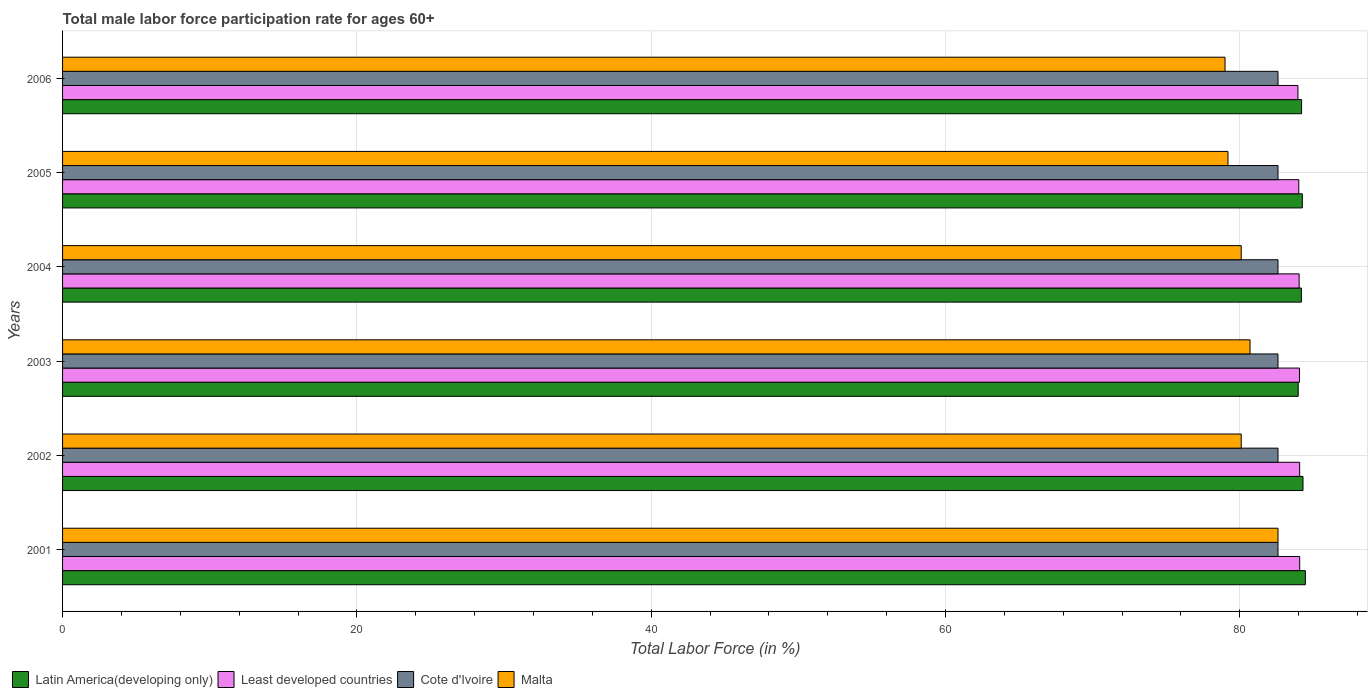How many different coloured bars are there?
Provide a succinct answer. 4. How many groups of bars are there?
Your answer should be compact. 6. How many bars are there on the 6th tick from the bottom?
Provide a short and direct response. 4. What is the label of the 4th group of bars from the top?
Provide a short and direct response. 2003. In how many cases, is the number of bars for a given year not equal to the number of legend labels?
Give a very brief answer. 0. What is the male labor force participation rate in Least developed countries in 2001?
Make the answer very short. 84.07. Across all years, what is the maximum male labor force participation rate in Cote d'Ivoire?
Your answer should be very brief. 82.6. Across all years, what is the minimum male labor force participation rate in Malta?
Provide a short and direct response. 79. In which year was the male labor force participation rate in Cote d'Ivoire minimum?
Your answer should be compact. 2001. What is the total male labor force participation rate in Malta in the graph?
Ensure brevity in your answer.  481.7. What is the difference between the male labor force participation rate in Cote d'Ivoire in 2001 and that in 2002?
Your answer should be compact. 0. What is the difference between the male labor force participation rate in Latin America(developing only) in 2003 and the male labor force participation rate in Least developed countries in 2002?
Make the answer very short. -0.1. What is the average male labor force participation rate in Least developed countries per year?
Provide a short and direct response. 84.04. In the year 2001, what is the difference between the male labor force participation rate in Least developed countries and male labor force participation rate in Latin America(developing only)?
Provide a short and direct response. -0.38. In how many years, is the male labor force participation rate in Latin America(developing only) greater than 24 %?
Your answer should be compact. 6. What is the ratio of the male labor force participation rate in Cote d'Ivoire in 2001 to that in 2003?
Your answer should be very brief. 1. Is the male labor force participation rate in Cote d'Ivoire in 2002 less than that in 2005?
Give a very brief answer. No. What is the difference between the highest and the second highest male labor force participation rate in Least developed countries?
Provide a succinct answer. 0. What is the difference between the highest and the lowest male labor force participation rate in Latin America(developing only)?
Give a very brief answer. 0.49. In how many years, is the male labor force participation rate in Cote d'Ivoire greater than the average male labor force participation rate in Cote d'Ivoire taken over all years?
Your answer should be very brief. 0. What does the 4th bar from the top in 2004 represents?
Keep it short and to the point. Latin America(developing only). What does the 3rd bar from the bottom in 2006 represents?
Keep it short and to the point. Cote d'Ivoire. Is it the case that in every year, the sum of the male labor force participation rate in Least developed countries and male labor force participation rate in Cote d'Ivoire is greater than the male labor force participation rate in Malta?
Keep it short and to the point. Yes. Are all the bars in the graph horizontal?
Your answer should be very brief. Yes. Are the values on the major ticks of X-axis written in scientific E-notation?
Keep it short and to the point. No. Does the graph contain grids?
Give a very brief answer. Yes. How many legend labels are there?
Offer a very short reply. 4. What is the title of the graph?
Your answer should be compact. Total male labor force participation rate for ages 60+. Does "Trinidad and Tobago" appear as one of the legend labels in the graph?
Your answer should be compact. No. What is the label or title of the X-axis?
Provide a short and direct response. Total Labor Force (in %). What is the label or title of the Y-axis?
Provide a short and direct response. Years. What is the Total Labor Force (in %) in Latin America(developing only) in 2001?
Provide a short and direct response. 84.46. What is the Total Labor Force (in %) in Least developed countries in 2001?
Ensure brevity in your answer.  84.07. What is the Total Labor Force (in %) of Cote d'Ivoire in 2001?
Offer a terse response. 82.6. What is the Total Labor Force (in %) of Malta in 2001?
Offer a terse response. 82.6. What is the Total Labor Force (in %) in Latin America(developing only) in 2002?
Provide a succinct answer. 84.3. What is the Total Labor Force (in %) of Least developed countries in 2002?
Your answer should be very brief. 84.07. What is the Total Labor Force (in %) of Cote d'Ivoire in 2002?
Your answer should be very brief. 82.6. What is the Total Labor Force (in %) of Malta in 2002?
Your response must be concise. 80.1. What is the Total Labor Force (in %) of Latin America(developing only) in 2003?
Ensure brevity in your answer.  83.97. What is the Total Labor Force (in %) in Least developed countries in 2003?
Offer a very short reply. 84.06. What is the Total Labor Force (in %) of Cote d'Ivoire in 2003?
Ensure brevity in your answer.  82.6. What is the Total Labor Force (in %) in Malta in 2003?
Keep it short and to the point. 80.7. What is the Total Labor Force (in %) of Latin America(developing only) in 2004?
Provide a short and direct response. 84.19. What is the Total Labor Force (in %) of Least developed countries in 2004?
Your answer should be compact. 84.04. What is the Total Labor Force (in %) in Cote d'Ivoire in 2004?
Your answer should be compact. 82.6. What is the Total Labor Force (in %) in Malta in 2004?
Provide a short and direct response. 80.1. What is the Total Labor Force (in %) in Latin America(developing only) in 2005?
Your response must be concise. 84.25. What is the Total Labor Force (in %) in Least developed countries in 2005?
Give a very brief answer. 84.01. What is the Total Labor Force (in %) of Cote d'Ivoire in 2005?
Make the answer very short. 82.6. What is the Total Labor Force (in %) of Malta in 2005?
Keep it short and to the point. 79.2. What is the Total Labor Force (in %) of Latin America(developing only) in 2006?
Ensure brevity in your answer.  84.2. What is the Total Labor Force (in %) in Least developed countries in 2006?
Give a very brief answer. 83.96. What is the Total Labor Force (in %) of Cote d'Ivoire in 2006?
Ensure brevity in your answer.  82.6. What is the Total Labor Force (in %) of Malta in 2006?
Offer a very short reply. 79. Across all years, what is the maximum Total Labor Force (in %) of Latin America(developing only)?
Provide a short and direct response. 84.46. Across all years, what is the maximum Total Labor Force (in %) in Least developed countries?
Offer a very short reply. 84.07. Across all years, what is the maximum Total Labor Force (in %) of Cote d'Ivoire?
Give a very brief answer. 82.6. Across all years, what is the maximum Total Labor Force (in %) in Malta?
Offer a terse response. 82.6. Across all years, what is the minimum Total Labor Force (in %) of Latin America(developing only)?
Offer a terse response. 83.97. Across all years, what is the minimum Total Labor Force (in %) of Least developed countries?
Keep it short and to the point. 83.96. Across all years, what is the minimum Total Labor Force (in %) of Cote d'Ivoire?
Offer a very short reply. 82.6. Across all years, what is the minimum Total Labor Force (in %) in Malta?
Your response must be concise. 79. What is the total Total Labor Force (in %) of Latin America(developing only) in the graph?
Make the answer very short. 505.38. What is the total Total Labor Force (in %) of Least developed countries in the graph?
Give a very brief answer. 504.22. What is the total Total Labor Force (in %) of Cote d'Ivoire in the graph?
Keep it short and to the point. 495.6. What is the total Total Labor Force (in %) in Malta in the graph?
Your answer should be very brief. 481.7. What is the difference between the Total Labor Force (in %) of Latin America(developing only) in 2001 and that in 2002?
Your response must be concise. 0.16. What is the difference between the Total Labor Force (in %) of Least developed countries in 2001 and that in 2002?
Provide a short and direct response. 0. What is the difference between the Total Labor Force (in %) of Cote d'Ivoire in 2001 and that in 2002?
Provide a short and direct response. 0. What is the difference between the Total Labor Force (in %) of Malta in 2001 and that in 2002?
Provide a succinct answer. 2.5. What is the difference between the Total Labor Force (in %) of Latin America(developing only) in 2001 and that in 2003?
Your response must be concise. 0.49. What is the difference between the Total Labor Force (in %) of Least developed countries in 2001 and that in 2003?
Provide a succinct answer. 0.01. What is the difference between the Total Labor Force (in %) in Latin America(developing only) in 2001 and that in 2004?
Offer a terse response. 0.27. What is the difference between the Total Labor Force (in %) in Least developed countries in 2001 and that in 2004?
Keep it short and to the point. 0.04. What is the difference between the Total Labor Force (in %) of Cote d'Ivoire in 2001 and that in 2004?
Provide a succinct answer. 0. What is the difference between the Total Labor Force (in %) of Latin America(developing only) in 2001 and that in 2005?
Your answer should be very brief. 0.21. What is the difference between the Total Labor Force (in %) of Least developed countries in 2001 and that in 2005?
Offer a terse response. 0.06. What is the difference between the Total Labor Force (in %) of Malta in 2001 and that in 2005?
Your answer should be very brief. 3.4. What is the difference between the Total Labor Force (in %) of Latin America(developing only) in 2001 and that in 2006?
Your answer should be very brief. 0.26. What is the difference between the Total Labor Force (in %) of Least developed countries in 2001 and that in 2006?
Keep it short and to the point. 0.12. What is the difference between the Total Labor Force (in %) in Latin America(developing only) in 2002 and that in 2003?
Offer a terse response. 0.33. What is the difference between the Total Labor Force (in %) in Latin America(developing only) in 2002 and that in 2004?
Give a very brief answer. 0.11. What is the difference between the Total Labor Force (in %) of Least developed countries in 2002 and that in 2004?
Your answer should be very brief. 0.04. What is the difference between the Total Labor Force (in %) in Latin America(developing only) in 2002 and that in 2005?
Ensure brevity in your answer.  0.05. What is the difference between the Total Labor Force (in %) in Least developed countries in 2002 and that in 2005?
Ensure brevity in your answer.  0.06. What is the difference between the Total Labor Force (in %) in Latin America(developing only) in 2002 and that in 2006?
Your answer should be compact. 0.1. What is the difference between the Total Labor Force (in %) of Least developed countries in 2002 and that in 2006?
Your response must be concise. 0.12. What is the difference between the Total Labor Force (in %) in Latin America(developing only) in 2003 and that in 2004?
Offer a terse response. -0.22. What is the difference between the Total Labor Force (in %) in Least developed countries in 2003 and that in 2004?
Give a very brief answer. 0.03. What is the difference between the Total Labor Force (in %) of Latin America(developing only) in 2003 and that in 2005?
Keep it short and to the point. -0.28. What is the difference between the Total Labor Force (in %) in Least developed countries in 2003 and that in 2005?
Ensure brevity in your answer.  0.05. What is the difference between the Total Labor Force (in %) of Cote d'Ivoire in 2003 and that in 2005?
Your answer should be very brief. 0. What is the difference between the Total Labor Force (in %) of Malta in 2003 and that in 2005?
Your answer should be compact. 1.5. What is the difference between the Total Labor Force (in %) of Latin America(developing only) in 2003 and that in 2006?
Keep it short and to the point. -0.23. What is the difference between the Total Labor Force (in %) of Least developed countries in 2003 and that in 2006?
Keep it short and to the point. 0.11. What is the difference between the Total Labor Force (in %) of Latin America(developing only) in 2004 and that in 2005?
Keep it short and to the point. -0.06. What is the difference between the Total Labor Force (in %) in Least developed countries in 2004 and that in 2005?
Offer a very short reply. 0.02. What is the difference between the Total Labor Force (in %) of Cote d'Ivoire in 2004 and that in 2005?
Ensure brevity in your answer.  0. What is the difference between the Total Labor Force (in %) in Latin America(developing only) in 2004 and that in 2006?
Your answer should be very brief. -0.01. What is the difference between the Total Labor Force (in %) in Latin America(developing only) in 2005 and that in 2006?
Your response must be concise. 0.05. What is the difference between the Total Labor Force (in %) of Least developed countries in 2005 and that in 2006?
Offer a very short reply. 0.06. What is the difference between the Total Labor Force (in %) in Cote d'Ivoire in 2005 and that in 2006?
Make the answer very short. 0. What is the difference between the Total Labor Force (in %) in Latin America(developing only) in 2001 and the Total Labor Force (in %) in Least developed countries in 2002?
Your answer should be very brief. 0.39. What is the difference between the Total Labor Force (in %) of Latin America(developing only) in 2001 and the Total Labor Force (in %) of Cote d'Ivoire in 2002?
Offer a very short reply. 1.86. What is the difference between the Total Labor Force (in %) in Latin America(developing only) in 2001 and the Total Labor Force (in %) in Malta in 2002?
Your response must be concise. 4.36. What is the difference between the Total Labor Force (in %) in Least developed countries in 2001 and the Total Labor Force (in %) in Cote d'Ivoire in 2002?
Make the answer very short. 1.47. What is the difference between the Total Labor Force (in %) in Least developed countries in 2001 and the Total Labor Force (in %) in Malta in 2002?
Your answer should be compact. 3.97. What is the difference between the Total Labor Force (in %) of Cote d'Ivoire in 2001 and the Total Labor Force (in %) of Malta in 2002?
Keep it short and to the point. 2.5. What is the difference between the Total Labor Force (in %) of Latin America(developing only) in 2001 and the Total Labor Force (in %) of Least developed countries in 2003?
Keep it short and to the point. 0.4. What is the difference between the Total Labor Force (in %) in Latin America(developing only) in 2001 and the Total Labor Force (in %) in Cote d'Ivoire in 2003?
Ensure brevity in your answer.  1.86. What is the difference between the Total Labor Force (in %) in Latin America(developing only) in 2001 and the Total Labor Force (in %) in Malta in 2003?
Your response must be concise. 3.76. What is the difference between the Total Labor Force (in %) in Least developed countries in 2001 and the Total Labor Force (in %) in Cote d'Ivoire in 2003?
Your answer should be very brief. 1.47. What is the difference between the Total Labor Force (in %) in Least developed countries in 2001 and the Total Labor Force (in %) in Malta in 2003?
Give a very brief answer. 3.37. What is the difference between the Total Labor Force (in %) of Cote d'Ivoire in 2001 and the Total Labor Force (in %) of Malta in 2003?
Give a very brief answer. 1.9. What is the difference between the Total Labor Force (in %) in Latin America(developing only) in 2001 and the Total Labor Force (in %) in Least developed countries in 2004?
Keep it short and to the point. 0.42. What is the difference between the Total Labor Force (in %) of Latin America(developing only) in 2001 and the Total Labor Force (in %) of Cote d'Ivoire in 2004?
Your answer should be compact. 1.86. What is the difference between the Total Labor Force (in %) in Latin America(developing only) in 2001 and the Total Labor Force (in %) in Malta in 2004?
Your response must be concise. 4.36. What is the difference between the Total Labor Force (in %) of Least developed countries in 2001 and the Total Labor Force (in %) of Cote d'Ivoire in 2004?
Your answer should be compact. 1.47. What is the difference between the Total Labor Force (in %) of Least developed countries in 2001 and the Total Labor Force (in %) of Malta in 2004?
Offer a very short reply. 3.97. What is the difference between the Total Labor Force (in %) in Latin America(developing only) in 2001 and the Total Labor Force (in %) in Least developed countries in 2005?
Ensure brevity in your answer.  0.45. What is the difference between the Total Labor Force (in %) in Latin America(developing only) in 2001 and the Total Labor Force (in %) in Cote d'Ivoire in 2005?
Offer a terse response. 1.86. What is the difference between the Total Labor Force (in %) in Latin America(developing only) in 2001 and the Total Labor Force (in %) in Malta in 2005?
Provide a short and direct response. 5.26. What is the difference between the Total Labor Force (in %) of Least developed countries in 2001 and the Total Labor Force (in %) of Cote d'Ivoire in 2005?
Give a very brief answer. 1.47. What is the difference between the Total Labor Force (in %) in Least developed countries in 2001 and the Total Labor Force (in %) in Malta in 2005?
Keep it short and to the point. 4.87. What is the difference between the Total Labor Force (in %) of Cote d'Ivoire in 2001 and the Total Labor Force (in %) of Malta in 2005?
Provide a short and direct response. 3.4. What is the difference between the Total Labor Force (in %) in Latin America(developing only) in 2001 and the Total Labor Force (in %) in Least developed countries in 2006?
Provide a succinct answer. 0.5. What is the difference between the Total Labor Force (in %) of Latin America(developing only) in 2001 and the Total Labor Force (in %) of Cote d'Ivoire in 2006?
Your answer should be very brief. 1.86. What is the difference between the Total Labor Force (in %) in Latin America(developing only) in 2001 and the Total Labor Force (in %) in Malta in 2006?
Offer a terse response. 5.46. What is the difference between the Total Labor Force (in %) in Least developed countries in 2001 and the Total Labor Force (in %) in Cote d'Ivoire in 2006?
Offer a terse response. 1.47. What is the difference between the Total Labor Force (in %) in Least developed countries in 2001 and the Total Labor Force (in %) in Malta in 2006?
Offer a terse response. 5.07. What is the difference between the Total Labor Force (in %) in Latin America(developing only) in 2002 and the Total Labor Force (in %) in Least developed countries in 2003?
Give a very brief answer. 0.24. What is the difference between the Total Labor Force (in %) of Latin America(developing only) in 2002 and the Total Labor Force (in %) of Cote d'Ivoire in 2003?
Provide a short and direct response. 1.7. What is the difference between the Total Labor Force (in %) of Latin America(developing only) in 2002 and the Total Labor Force (in %) of Malta in 2003?
Your answer should be compact. 3.6. What is the difference between the Total Labor Force (in %) of Least developed countries in 2002 and the Total Labor Force (in %) of Cote d'Ivoire in 2003?
Make the answer very short. 1.47. What is the difference between the Total Labor Force (in %) of Least developed countries in 2002 and the Total Labor Force (in %) of Malta in 2003?
Provide a short and direct response. 3.37. What is the difference between the Total Labor Force (in %) in Latin America(developing only) in 2002 and the Total Labor Force (in %) in Least developed countries in 2004?
Offer a terse response. 0.26. What is the difference between the Total Labor Force (in %) of Latin America(developing only) in 2002 and the Total Labor Force (in %) of Cote d'Ivoire in 2004?
Your answer should be very brief. 1.7. What is the difference between the Total Labor Force (in %) in Latin America(developing only) in 2002 and the Total Labor Force (in %) in Malta in 2004?
Ensure brevity in your answer.  4.2. What is the difference between the Total Labor Force (in %) of Least developed countries in 2002 and the Total Labor Force (in %) of Cote d'Ivoire in 2004?
Your response must be concise. 1.47. What is the difference between the Total Labor Force (in %) in Least developed countries in 2002 and the Total Labor Force (in %) in Malta in 2004?
Give a very brief answer. 3.97. What is the difference between the Total Labor Force (in %) of Cote d'Ivoire in 2002 and the Total Labor Force (in %) of Malta in 2004?
Your answer should be compact. 2.5. What is the difference between the Total Labor Force (in %) in Latin America(developing only) in 2002 and the Total Labor Force (in %) in Least developed countries in 2005?
Provide a succinct answer. 0.29. What is the difference between the Total Labor Force (in %) of Latin America(developing only) in 2002 and the Total Labor Force (in %) of Cote d'Ivoire in 2005?
Keep it short and to the point. 1.7. What is the difference between the Total Labor Force (in %) of Latin America(developing only) in 2002 and the Total Labor Force (in %) of Malta in 2005?
Your response must be concise. 5.1. What is the difference between the Total Labor Force (in %) of Least developed countries in 2002 and the Total Labor Force (in %) of Cote d'Ivoire in 2005?
Offer a very short reply. 1.47. What is the difference between the Total Labor Force (in %) of Least developed countries in 2002 and the Total Labor Force (in %) of Malta in 2005?
Provide a short and direct response. 4.87. What is the difference between the Total Labor Force (in %) in Cote d'Ivoire in 2002 and the Total Labor Force (in %) in Malta in 2005?
Provide a succinct answer. 3.4. What is the difference between the Total Labor Force (in %) in Latin America(developing only) in 2002 and the Total Labor Force (in %) in Least developed countries in 2006?
Offer a very short reply. 0.34. What is the difference between the Total Labor Force (in %) of Latin America(developing only) in 2002 and the Total Labor Force (in %) of Cote d'Ivoire in 2006?
Offer a very short reply. 1.7. What is the difference between the Total Labor Force (in %) in Latin America(developing only) in 2002 and the Total Labor Force (in %) in Malta in 2006?
Ensure brevity in your answer.  5.3. What is the difference between the Total Labor Force (in %) of Least developed countries in 2002 and the Total Labor Force (in %) of Cote d'Ivoire in 2006?
Keep it short and to the point. 1.47. What is the difference between the Total Labor Force (in %) in Least developed countries in 2002 and the Total Labor Force (in %) in Malta in 2006?
Your answer should be very brief. 5.07. What is the difference between the Total Labor Force (in %) in Latin America(developing only) in 2003 and the Total Labor Force (in %) in Least developed countries in 2004?
Provide a succinct answer. -0.06. What is the difference between the Total Labor Force (in %) of Latin America(developing only) in 2003 and the Total Labor Force (in %) of Cote d'Ivoire in 2004?
Your response must be concise. 1.37. What is the difference between the Total Labor Force (in %) in Latin America(developing only) in 2003 and the Total Labor Force (in %) in Malta in 2004?
Give a very brief answer. 3.87. What is the difference between the Total Labor Force (in %) of Least developed countries in 2003 and the Total Labor Force (in %) of Cote d'Ivoire in 2004?
Offer a very short reply. 1.46. What is the difference between the Total Labor Force (in %) in Least developed countries in 2003 and the Total Labor Force (in %) in Malta in 2004?
Provide a short and direct response. 3.96. What is the difference between the Total Labor Force (in %) in Cote d'Ivoire in 2003 and the Total Labor Force (in %) in Malta in 2004?
Offer a terse response. 2.5. What is the difference between the Total Labor Force (in %) in Latin America(developing only) in 2003 and the Total Labor Force (in %) in Least developed countries in 2005?
Ensure brevity in your answer.  -0.04. What is the difference between the Total Labor Force (in %) of Latin America(developing only) in 2003 and the Total Labor Force (in %) of Cote d'Ivoire in 2005?
Offer a terse response. 1.37. What is the difference between the Total Labor Force (in %) in Latin America(developing only) in 2003 and the Total Labor Force (in %) in Malta in 2005?
Provide a short and direct response. 4.77. What is the difference between the Total Labor Force (in %) of Least developed countries in 2003 and the Total Labor Force (in %) of Cote d'Ivoire in 2005?
Your answer should be compact. 1.46. What is the difference between the Total Labor Force (in %) of Least developed countries in 2003 and the Total Labor Force (in %) of Malta in 2005?
Keep it short and to the point. 4.86. What is the difference between the Total Labor Force (in %) in Cote d'Ivoire in 2003 and the Total Labor Force (in %) in Malta in 2005?
Make the answer very short. 3.4. What is the difference between the Total Labor Force (in %) in Latin America(developing only) in 2003 and the Total Labor Force (in %) in Least developed countries in 2006?
Keep it short and to the point. 0.02. What is the difference between the Total Labor Force (in %) of Latin America(developing only) in 2003 and the Total Labor Force (in %) of Cote d'Ivoire in 2006?
Provide a succinct answer. 1.37. What is the difference between the Total Labor Force (in %) of Latin America(developing only) in 2003 and the Total Labor Force (in %) of Malta in 2006?
Offer a very short reply. 4.97. What is the difference between the Total Labor Force (in %) in Least developed countries in 2003 and the Total Labor Force (in %) in Cote d'Ivoire in 2006?
Offer a very short reply. 1.46. What is the difference between the Total Labor Force (in %) of Least developed countries in 2003 and the Total Labor Force (in %) of Malta in 2006?
Provide a short and direct response. 5.06. What is the difference between the Total Labor Force (in %) of Latin America(developing only) in 2004 and the Total Labor Force (in %) of Least developed countries in 2005?
Keep it short and to the point. 0.18. What is the difference between the Total Labor Force (in %) in Latin America(developing only) in 2004 and the Total Labor Force (in %) in Cote d'Ivoire in 2005?
Your answer should be very brief. 1.59. What is the difference between the Total Labor Force (in %) in Latin America(developing only) in 2004 and the Total Labor Force (in %) in Malta in 2005?
Offer a terse response. 4.99. What is the difference between the Total Labor Force (in %) of Least developed countries in 2004 and the Total Labor Force (in %) of Cote d'Ivoire in 2005?
Provide a succinct answer. 1.44. What is the difference between the Total Labor Force (in %) in Least developed countries in 2004 and the Total Labor Force (in %) in Malta in 2005?
Keep it short and to the point. 4.84. What is the difference between the Total Labor Force (in %) in Latin America(developing only) in 2004 and the Total Labor Force (in %) in Least developed countries in 2006?
Your answer should be compact. 0.23. What is the difference between the Total Labor Force (in %) of Latin America(developing only) in 2004 and the Total Labor Force (in %) of Cote d'Ivoire in 2006?
Offer a very short reply. 1.59. What is the difference between the Total Labor Force (in %) in Latin America(developing only) in 2004 and the Total Labor Force (in %) in Malta in 2006?
Your answer should be compact. 5.19. What is the difference between the Total Labor Force (in %) in Least developed countries in 2004 and the Total Labor Force (in %) in Cote d'Ivoire in 2006?
Provide a short and direct response. 1.44. What is the difference between the Total Labor Force (in %) of Least developed countries in 2004 and the Total Labor Force (in %) of Malta in 2006?
Provide a short and direct response. 5.04. What is the difference between the Total Labor Force (in %) of Cote d'Ivoire in 2004 and the Total Labor Force (in %) of Malta in 2006?
Offer a very short reply. 3.6. What is the difference between the Total Labor Force (in %) in Latin America(developing only) in 2005 and the Total Labor Force (in %) in Least developed countries in 2006?
Provide a short and direct response. 0.3. What is the difference between the Total Labor Force (in %) in Latin America(developing only) in 2005 and the Total Labor Force (in %) in Cote d'Ivoire in 2006?
Offer a very short reply. 1.65. What is the difference between the Total Labor Force (in %) in Latin America(developing only) in 2005 and the Total Labor Force (in %) in Malta in 2006?
Ensure brevity in your answer.  5.25. What is the difference between the Total Labor Force (in %) in Least developed countries in 2005 and the Total Labor Force (in %) in Cote d'Ivoire in 2006?
Make the answer very short. 1.41. What is the difference between the Total Labor Force (in %) in Least developed countries in 2005 and the Total Labor Force (in %) in Malta in 2006?
Provide a succinct answer. 5.01. What is the difference between the Total Labor Force (in %) in Cote d'Ivoire in 2005 and the Total Labor Force (in %) in Malta in 2006?
Keep it short and to the point. 3.6. What is the average Total Labor Force (in %) of Latin America(developing only) per year?
Ensure brevity in your answer.  84.23. What is the average Total Labor Force (in %) of Least developed countries per year?
Provide a succinct answer. 84.04. What is the average Total Labor Force (in %) in Cote d'Ivoire per year?
Offer a very short reply. 82.6. What is the average Total Labor Force (in %) of Malta per year?
Ensure brevity in your answer.  80.28. In the year 2001, what is the difference between the Total Labor Force (in %) of Latin America(developing only) and Total Labor Force (in %) of Least developed countries?
Make the answer very short. 0.38. In the year 2001, what is the difference between the Total Labor Force (in %) in Latin America(developing only) and Total Labor Force (in %) in Cote d'Ivoire?
Your answer should be very brief. 1.86. In the year 2001, what is the difference between the Total Labor Force (in %) in Latin America(developing only) and Total Labor Force (in %) in Malta?
Offer a terse response. 1.86. In the year 2001, what is the difference between the Total Labor Force (in %) in Least developed countries and Total Labor Force (in %) in Cote d'Ivoire?
Keep it short and to the point. 1.47. In the year 2001, what is the difference between the Total Labor Force (in %) of Least developed countries and Total Labor Force (in %) of Malta?
Keep it short and to the point. 1.47. In the year 2001, what is the difference between the Total Labor Force (in %) in Cote d'Ivoire and Total Labor Force (in %) in Malta?
Your response must be concise. 0. In the year 2002, what is the difference between the Total Labor Force (in %) of Latin America(developing only) and Total Labor Force (in %) of Least developed countries?
Keep it short and to the point. 0.23. In the year 2002, what is the difference between the Total Labor Force (in %) in Latin America(developing only) and Total Labor Force (in %) in Cote d'Ivoire?
Ensure brevity in your answer.  1.7. In the year 2002, what is the difference between the Total Labor Force (in %) in Latin America(developing only) and Total Labor Force (in %) in Malta?
Offer a terse response. 4.2. In the year 2002, what is the difference between the Total Labor Force (in %) of Least developed countries and Total Labor Force (in %) of Cote d'Ivoire?
Your answer should be compact. 1.47. In the year 2002, what is the difference between the Total Labor Force (in %) of Least developed countries and Total Labor Force (in %) of Malta?
Keep it short and to the point. 3.97. In the year 2003, what is the difference between the Total Labor Force (in %) of Latin America(developing only) and Total Labor Force (in %) of Least developed countries?
Provide a short and direct response. -0.09. In the year 2003, what is the difference between the Total Labor Force (in %) of Latin America(developing only) and Total Labor Force (in %) of Cote d'Ivoire?
Your response must be concise. 1.37. In the year 2003, what is the difference between the Total Labor Force (in %) of Latin America(developing only) and Total Labor Force (in %) of Malta?
Offer a very short reply. 3.27. In the year 2003, what is the difference between the Total Labor Force (in %) of Least developed countries and Total Labor Force (in %) of Cote d'Ivoire?
Keep it short and to the point. 1.46. In the year 2003, what is the difference between the Total Labor Force (in %) in Least developed countries and Total Labor Force (in %) in Malta?
Provide a succinct answer. 3.36. In the year 2004, what is the difference between the Total Labor Force (in %) in Latin America(developing only) and Total Labor Force (in %) in Least developed countries?
Offer a terse response. 0.15. In the year 2004, what is the difference between the Total Labor Force (in %) in Latin America(developing only) and Total Labor Force (in %) in Cote d'Ivoire?
Your answer should be compact. 1.59. In the year 2004, what is the difference between the Total Labor Force (in %) in Latin America(developing only) and Total Labor Force (in %) in Malta?
Your response must be concise. 4.09. In the year 2004, what is the difference between the Total Labor Force (in %) of Least developed countries and Total Labor Force (in %) of Cote d'Ivoire?
Your answer should be very brief. 1.44. In the year 2004, what is the difference between the Total Labor Force (in %) in Least developed countries and Total Labor Force (in %) in Malta?
Provide a short and direct response. 3.94. In the year 2005, what is the difference between the Total Labor Force (in %) of Latin America(developing only) and Total Labor Force (in %) of Least developed countries?
Give a very brief answer. 0.24. In the year 2005, what is the difference between the Total Labor Force (in %) of Latin America(developing only) and Total Labor Force (in %) of Cote d'Ivoire?
Your answer should be very brief. 1.65. In the year 2005, what is the difference between the Total Labor Force (in %) of Latin America(developing only) and Total Labor Force (in %) of Malta?
Ensure brevity in your answer.  5.05. In the year 2005, what is the difference between the Total Labor Force (in %) in Least developed countries and Total Labor Force (in %) in Cote d'Ivoire?
Give a very brief answer. 1.41. In the year 2005, what is the difference between the Total Labor Force (in %) of Least developed countries and Total Labor Force (in %) of Malta?
Keep it short and to the point. 4.81. In the year 2006, what is the difference between the Total Labor Force (in %) of Latin America(developing only) and Total Labor Force (in %) of Least developed countries?
Make the answer very short. 0.25. In the year 2006, what is the difference between the Total Labor Force (in %) in Latin America(developing only) and Total Labor Force (in %) in Cote d'Ivoire?
Make the answer very short. 1.6. In the year 2006, what is the difference between the Total Labor Force (in %) of Latin America(developing only) and Total Labor Force (in %) of Malta?
Offer a very short reply. 5.2. In the year 2006, what is the difference between the Total Labor Force (in %) in Least developed countries and Total Labor Force (in %) in Cote d'Ivoire?
Your answer should be compact. 1.36. In the year 2006, what is the difference between the Total Labor Force (in %) of Least developed countries and Total Labor Force (in %) of Malta?
Make the answer very short. 4.96. What is the ratio of the Total Labor Force (in %) in Latin America(developing only) in 2001 to that in 2002?
Your answer should be compact. 1. What is the ratio of the Total Labor Force (in %) in Malta in 2001 to that in 2002?
Give a very brief answer. 1.03. What is the ratio of the Total Labor Force (in %) of Cote d'Ivoire in 2001 to that in 2003?
Offer a very short reply. 1. What is the ratio of the Total Labor Force (in %) in Malta in 2001 to that in 2003?
Provide a succinct answer. 1.02. What is the ratio of the Total Labor Force (in %) in Cote d'Ivoire in 2001 to that in 2004?
Offer a terse response. 1. What is the ratio of the Total Labor Force (in %) of Malta in 2001 to that in 2004?
Give a very brief answer. 1.03. What is the ratio of the Total Labor Force (in %) in Latin America(developing only) in 2001 to that in 2005?
Give a very brief answer. 1. What is the ratio of the Total Labor Force (in %) of Least developed countries in 2001 to that in 2005?
Keep it short and to the point. 1. What is the ratio of the Total Labor Force (in %) of Malta in 2001 to that in 2005?
Your response must be concise. 1.04. What is the ratio of the Total Labor Force (in %) of Least developed countries in 2001 to that in 2006?
Your response must be concise. 1. What is the ratio of the Total Labor Force (in %) in Malta in 2001 to that in 2006?
Keep it short and to the point. 1.05. What is the ratio of the Total Labor Force (in %) of Latin America(developing only) in 2002 to that in 2003?
Give a very brief answer. 1. What is the ratio of the Total Labor Force (in %) in Cote d'Ivoire in 2002 to that in 2003?
Provide a succinct answer. 1. What is the ratio of the Total Labor Force (in %) of Malta in 2002 to that in 2003?
Your answer should be very brief. 0.99. What is the ratio of the Total Labor Force (in %) in Least developed countries in 2002 to that in 2004?
Give a very brief answer. 1. What is the ratio of the Total Labor Force (in %) of Cote d'Ivoire in 2002 to that in 2004?
Your answer should be very brief. 1. What is the ratio of the Total Labor Force (in %) in Latin America(developing only) in 2002 to that in 2005?
Ensure brevity in your answer.  1. What is the ratio of the Total Labor Force (in %) in Cote d'Ivoire in 2002 to that in 2005?
Offer a terse response. 1. What is the ratio of the Total Labor Force (in %) in Malta in 2002 to that in 2005?
Ensure brevity in your answer.  1.01. What is the ratio of the Total Labor Force (in %) in Latin America(developing only) in 2002 to that in 2006?
Offer a terse response. 1. What is the ratio of the Total Labor Force (in %) of Least developed countries in 2002 to that in 2006?
Ensure brevity in your answer.  1. What is the ratio of the Total Labor Force (in %) in Cote d'Ivoire in 2002 to that in 2006?
Your answer should be very brief. 1. What is the ratio of the Total Labor Force (in %) in Malta in 2002 to that in 2006?
Make the answer very short. 1.01. What is the ratio of the Total Labor Force (in %) of Latin America(developing only) in 2003 to that in 2004?
Provide a succinct answer. 1. What is the ratio of the Total Labor Force (in %) in Least developed countries in 2003 to that in 2004?
Provide a short and direct response. 1. What is the ratio of the Total Labor Force (in %) in Malta in 2003 to that in 2004?
Keep it short and to the point. 1.01. What is the ratio of the Total Labor Force (in %) of Least developed countries in 2003 to that in 2005?
Provide a short and direct response. 1. What is the ratio of the Total Labor Force (in %) in Malta in 2003 to that in 2005?
Give a very brief answer. 1.02. What is the ratio of the Total Labor Force (in %) of Least developed countries in 2003 to that in 2006?
Offer a very short reply. 1. What is the ratio of the Total Labor Force (in %) of Cote d'Ivoire in 2003 to that in 2006?
Provide a short and direct response. 1. What is the ratio of the Total Labor Force (in %) of Malta in 2003 to that in 2006?
Your response must be concise. 1.02. What is the ratio of the Total Labor Force (in %) in Latin America(developing only) in 2004 to that in 2005?
Ensure brevity in your answer.  1. What is the ratio of the Total Labor Force (in %) of Cote d'Ivoire in 2004 to that in 2005?
Give a very brief answer. 1. What is the ratio of the Total Labor Force (in %) in Malta in 2004 to that in 2005?
Ensure brevity in your answer.  1.01. What is the ratio of the Total Labor Force (in %) in Latin America(developing only) in 2004 to that in 2006?
Offer a terse response. 1. What is the ratio of the Total Labor Force (in %) in Least developed countries in 2004 to that in 2006?
Provide a short and direct response. 1. What is the ratio of the Total Labor Force (in %) of Cote d'Ivoire in 2004 to that in 2006?
Make the answer very short. 1. What is the ratio of the Total Labor Force (in %) in Malta in 2004 to that in 2006?
Your answer should be compact. 1.01. What is the ratio of the Total Labor Force (in %) of Least developed countries in 2005 to that in 2006?
Your answer should be compact. 1. What is the difference between the highest and the second highest Total Labor Force (in %) in Latin America(developing only)?
Make the answer very short. 0.16. What is the difference between the highest and the second highest Total Labor Force (in %) in Least developed countries?
Your answer should be compact. 0. What is the difference between the highest and the second highest Total Labor Force (in %) of Cote d'Ivoire?
Ensure brevity in your answer.  0. What is the difference between the highest and the second highest Total Labor Force (in %) in Malta?
Your answer should be compact. 1.9. What is the difference between the highest and the lowest Total Labor Force (in %) in Latin America(developing only)?
Offer a very short reply. 0.49. What is the difference between the highest and the lowest Total Labor Force (in %) in Least developed countries?
Make the answer very short. 0.12. What is the difference between the highest and the lowest Total Labor Force (in %) of Cote d'Ivoire?
Ensure brevity in your answer.  0. What is the difference between the highest and the lowest Total Labor Force (in %) of Malta?
Ensure brevity in your answer.  3.6. 